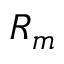Convert formula to latex. <formula><loc_0><loc_0><loc_500><loc_500>R _ { m }</formula> 